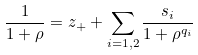<formula> <loc_0><loc_0><loc_500><loc_500>\frac { 1 } { 1 + \rho } = z _ { + } + \sum _ { i = 1 , 2 } \frac { s _ { i } } { 1 + \rho ^ { q _ { i } } }</formula> 